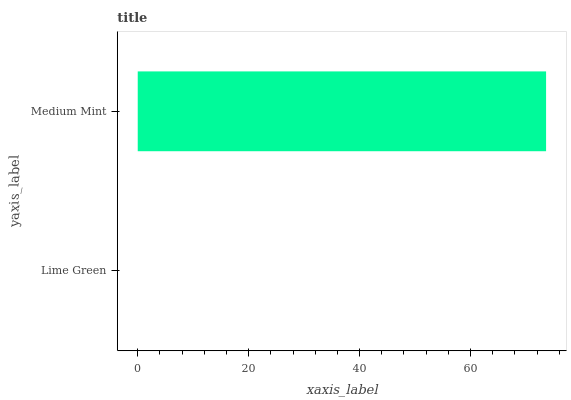Is Lime Green the minimum?
Answer yes or no. Yes. Is Medium Mint the maximum?
Answer yes or no. Yes. Is Medium Mint the minimum?
Answer yes or no. No. Is Medium Mint greater than Lime Green?
Answer yes or no. Yes. Is Lime Green less than Medium Mint?
Answer yes or no. Yes. Is Lime Green greater than Medium Mint?
Answer yes or no. No. Is Medium Mint less than Lime Green?
Answer yes or no. No. Is Medium Mint the high median?
Answer yes or no. Yes. Is Lime Green the low median?
Answer yes or no. Yes. Is Lime Green the high median?
Answer yes or no. No. Is Medium Mint the low median?
Answer yes or no. No. 